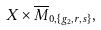Convert formula to latex. <formula><loc_0><loc_0><loc_500><loc_500>X \times \overline { M } _ { 0 , \{ g _ { 2 } , r , s \} } ,</formula> 